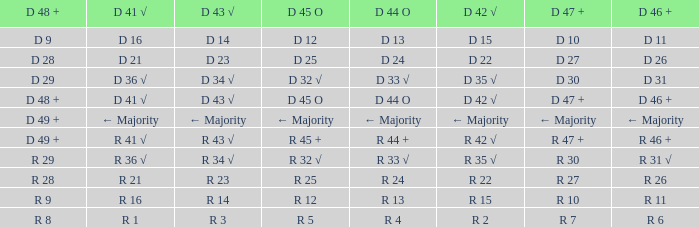What is the value of D 42 √, when the value of D 45 O is d 32 √? D 35 √. 